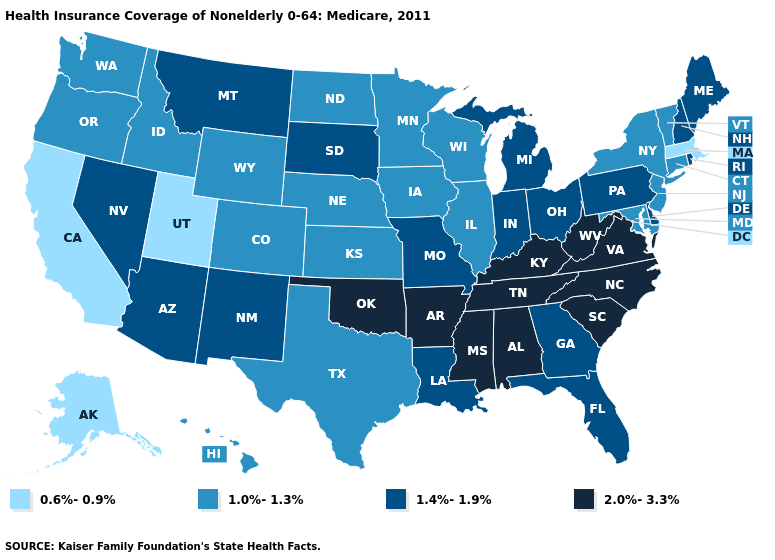Does Alaska have the lowest value in the USA?
Short answer required. Yes. What is the value of North Carolina?
Answer briefly. 2.0%-3.3%. What is the value of South Carolina?
Concise answer only. 2.0%-3.3%. Does South Dakota have the highest value in the MidWest?
Write a very short answer. Yes. What is the value of Oklahoma?
Keep it brief. 2.0%-3.3%. Name the states that have a value in the range 0.6%-0.9%?
Give a very brief answer. Alaska, California, Massachusetts, Utah. What is the value of Oregon?
Write a very short answer. 1.0%-1.3%. Does Alaska have a lower value than California?
Quick response, please. No. What is the lowest value in states that border Maryland?
Concise answer only. 1.4%-1.9%. What is the lowest value in the USA?
Give a very brief answer. 0.6%-0.9%. What is the lowest value in the Northeast?
Answer briefly. 0.6%-0.9%. What is the highest value in states that border Oklahoma?
Short answer required. 2.0%-3.3%. What is the lowest value in the USA?
Short answer required. 0.6%-0.9%. Among the states that border Delaware , does New Jersey have the highest value?
Keep it brief. No. Does California have the lowest value in the USA?
Give a very brief answer. Yes. 